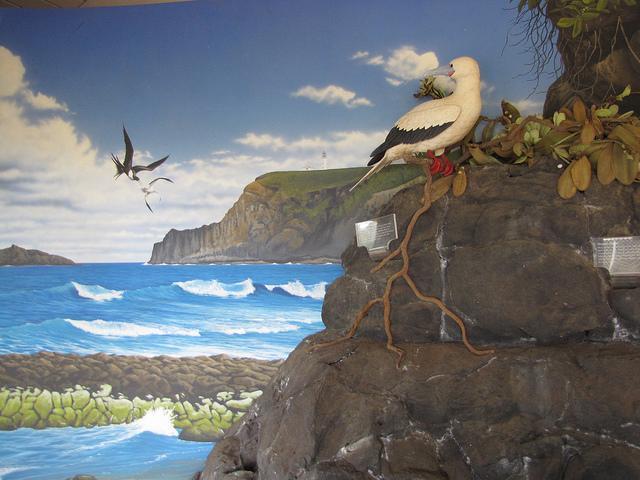How many birds are there?
Give a very brief answer. 3. 